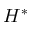<formula> <loc_0><loc_0><loc_500><loc_500>H ^ { * }</formula> 